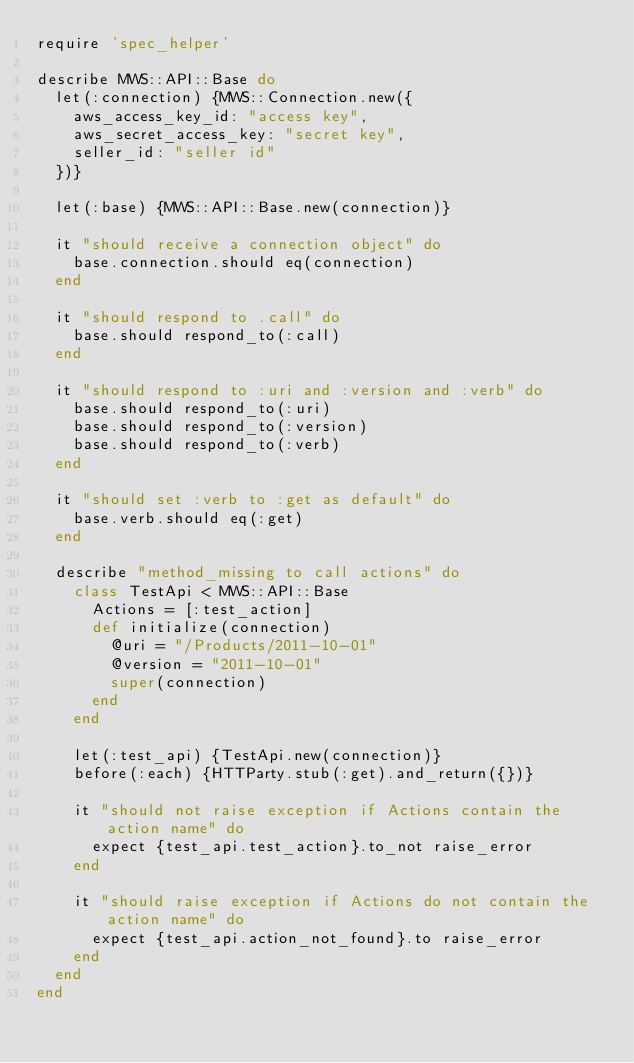Convert code to text. <code><loc_0><loc_0><loc_500><loc_500><_Ruby_>require 'spec_helper'

describe MWS::API::Base do
  let(:connection) {MWS::Connection.new({
    aws_access_key_id: "access key",
    aws_secret_access_key: "secret key",
    seller_id: "seller id"
  })}

  let(:base) {MWS::API::Base.new(connection)}

  it "should receive a connection object" do
    base.connection.should eq(connection)
  end

  it "should respond to .call" do
    base.should respond_to(:call)
  end

  it "should respond to :uri and :version and :verb" do
    base.should respond_to(:uri)
    base.should respond_to(:version)
    base.should respond_to(:verb)
  end

  it "should set :verb to :get as default" do
    base.verb.should eq(:get)
  end

  describe "method_missing to call actions" do
    class TestApi < MWS::API::Base
      Actions = [:test_action]
      def initialize(connection)
        @uri = "/Products/2011-10-01"
        @version = "2011-10-01"
        super(connection)
      end
    end

    let(:test_api) {TestApi.new(connection)}
    before(:each) {HTTParty.stub(:get).and_return({})}

    it "should not raise exception if Actions contain the action name" do
      expect {test_api.test_action}.to_not raise_error
    end

    it "should raise exception if Actions do not contain the action name" do
      expect {test_api.action_not_found}.to raise_error
    end
  end
end
</code> 